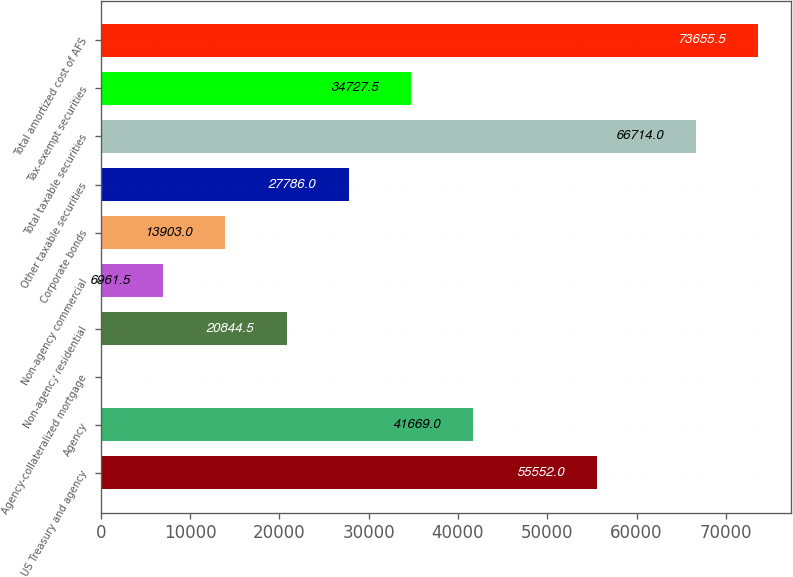<chart> <loc_0><loc_0><loc_500><loc_500><bar_chart><fcel>US Treasury and agency<fcel>Agency<fcel>Agency-collateralized mortgage<fcel>Non-agency residential<fcel>Non-agency commercial<fcel>Corporate bonds<fcel>Other taxable securities<fcel>Total taxable securities<fcel>Tax-exempt securities<fcel>Total amortized cost of AFS<nl><fcel>55552<fcel>41669<fcel>20<fcel>20844.5<fcel>6961.5<fcel>13903<fcel>27786<fcel>66714<fcel>34727.5<fcel>73655.5<nl></chart> 